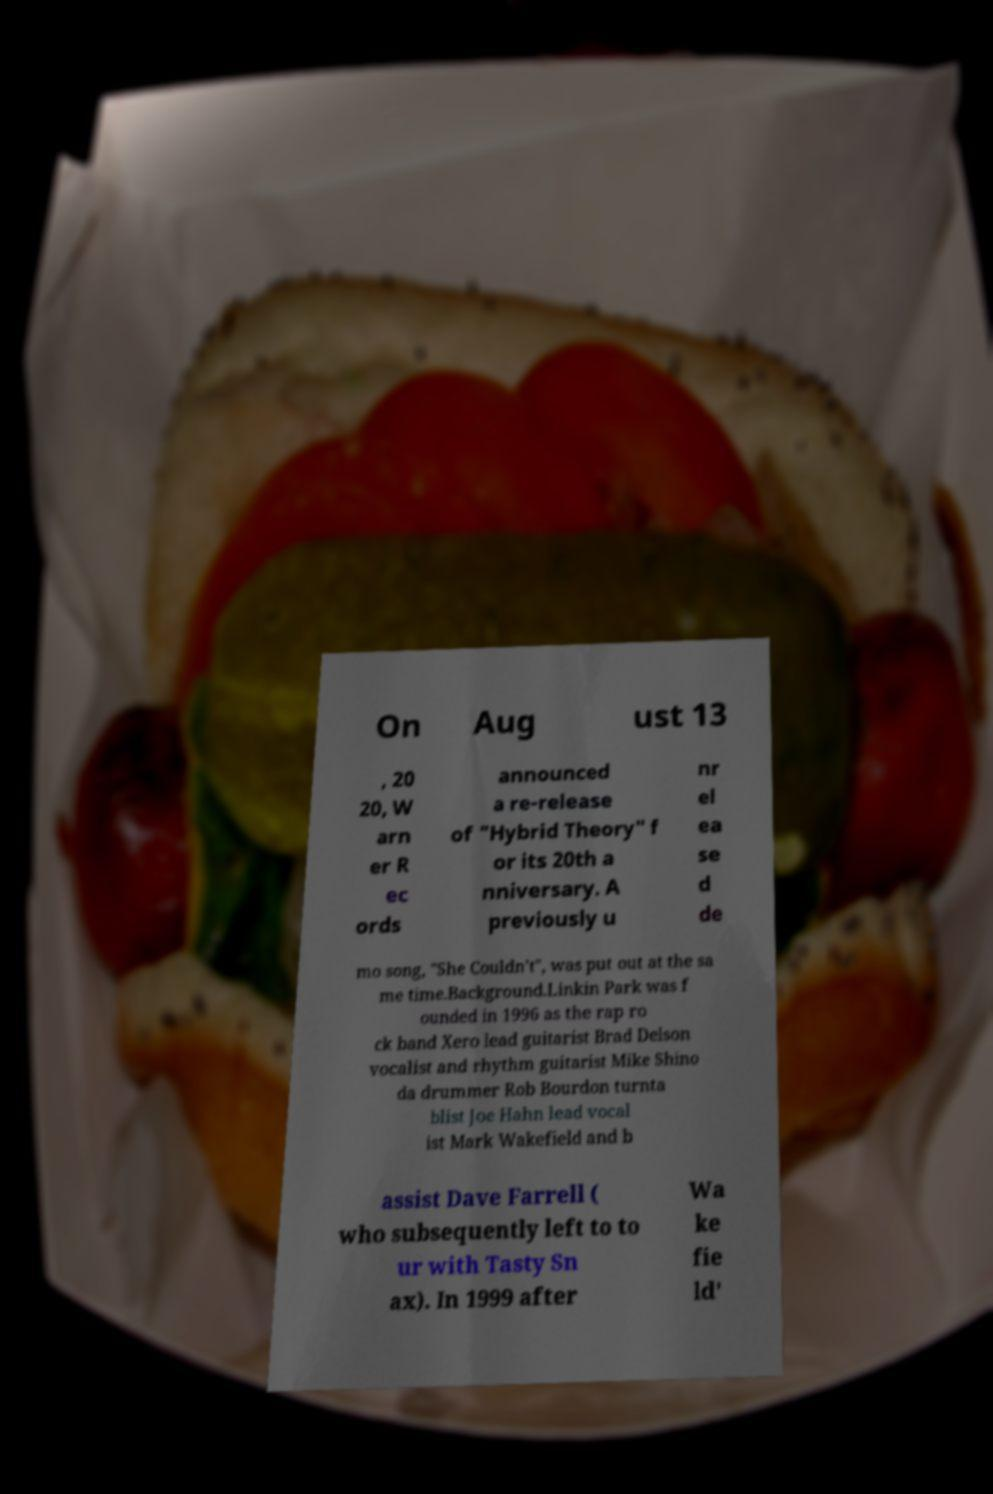I need the written content from this picture converted into text. Can you do that? On Aug ust 13 , 20 20, W arn er R ec ords announced a re-release of "Hybrid Theory" f or its 20th a nniversary. A previously u nr el ea se d de mo song, "She Couldn't", was put out at the sa me time.Background.Linkin Park was f ounded in 1996 as the rap ro ck band Xero lead guitarist Brad Delson vocalist and rhythm guitarist Mike Shino da drummer Rob Bourdon turnta blist Joe Hahn lead vocal ist Mark Wakefield and b assist Dave Farrell ( who subsequently left to to ur with Tasty Sn ax). In 1999 after Wa ke fie ld' 